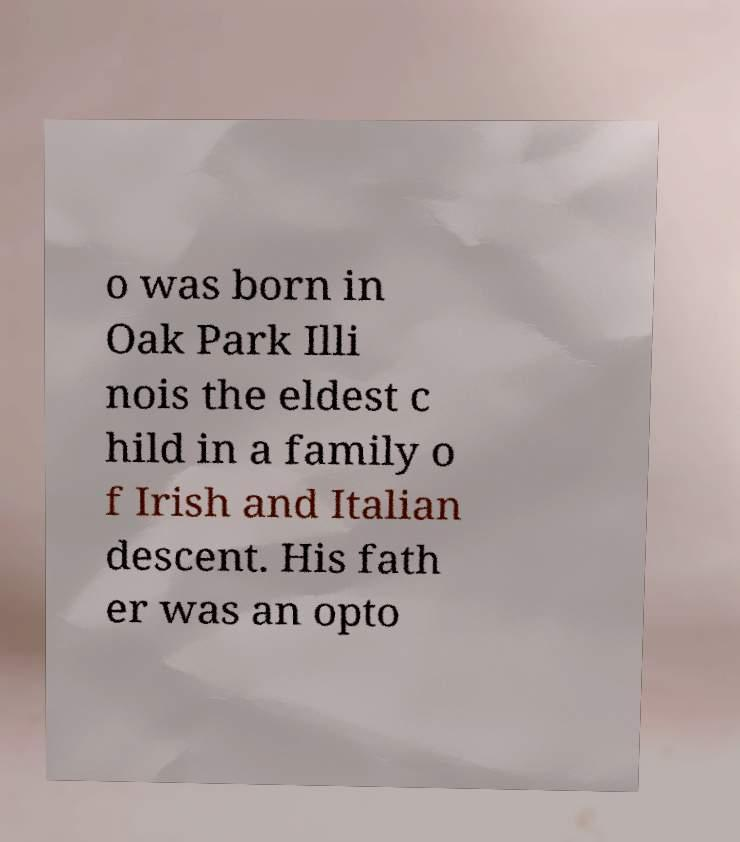Please read and relay the text visible in this image. What does it say? o was born in Oak Park Illi nois the eldest c hild in a family o f Irish and Italian descent. His fath er was an opto 